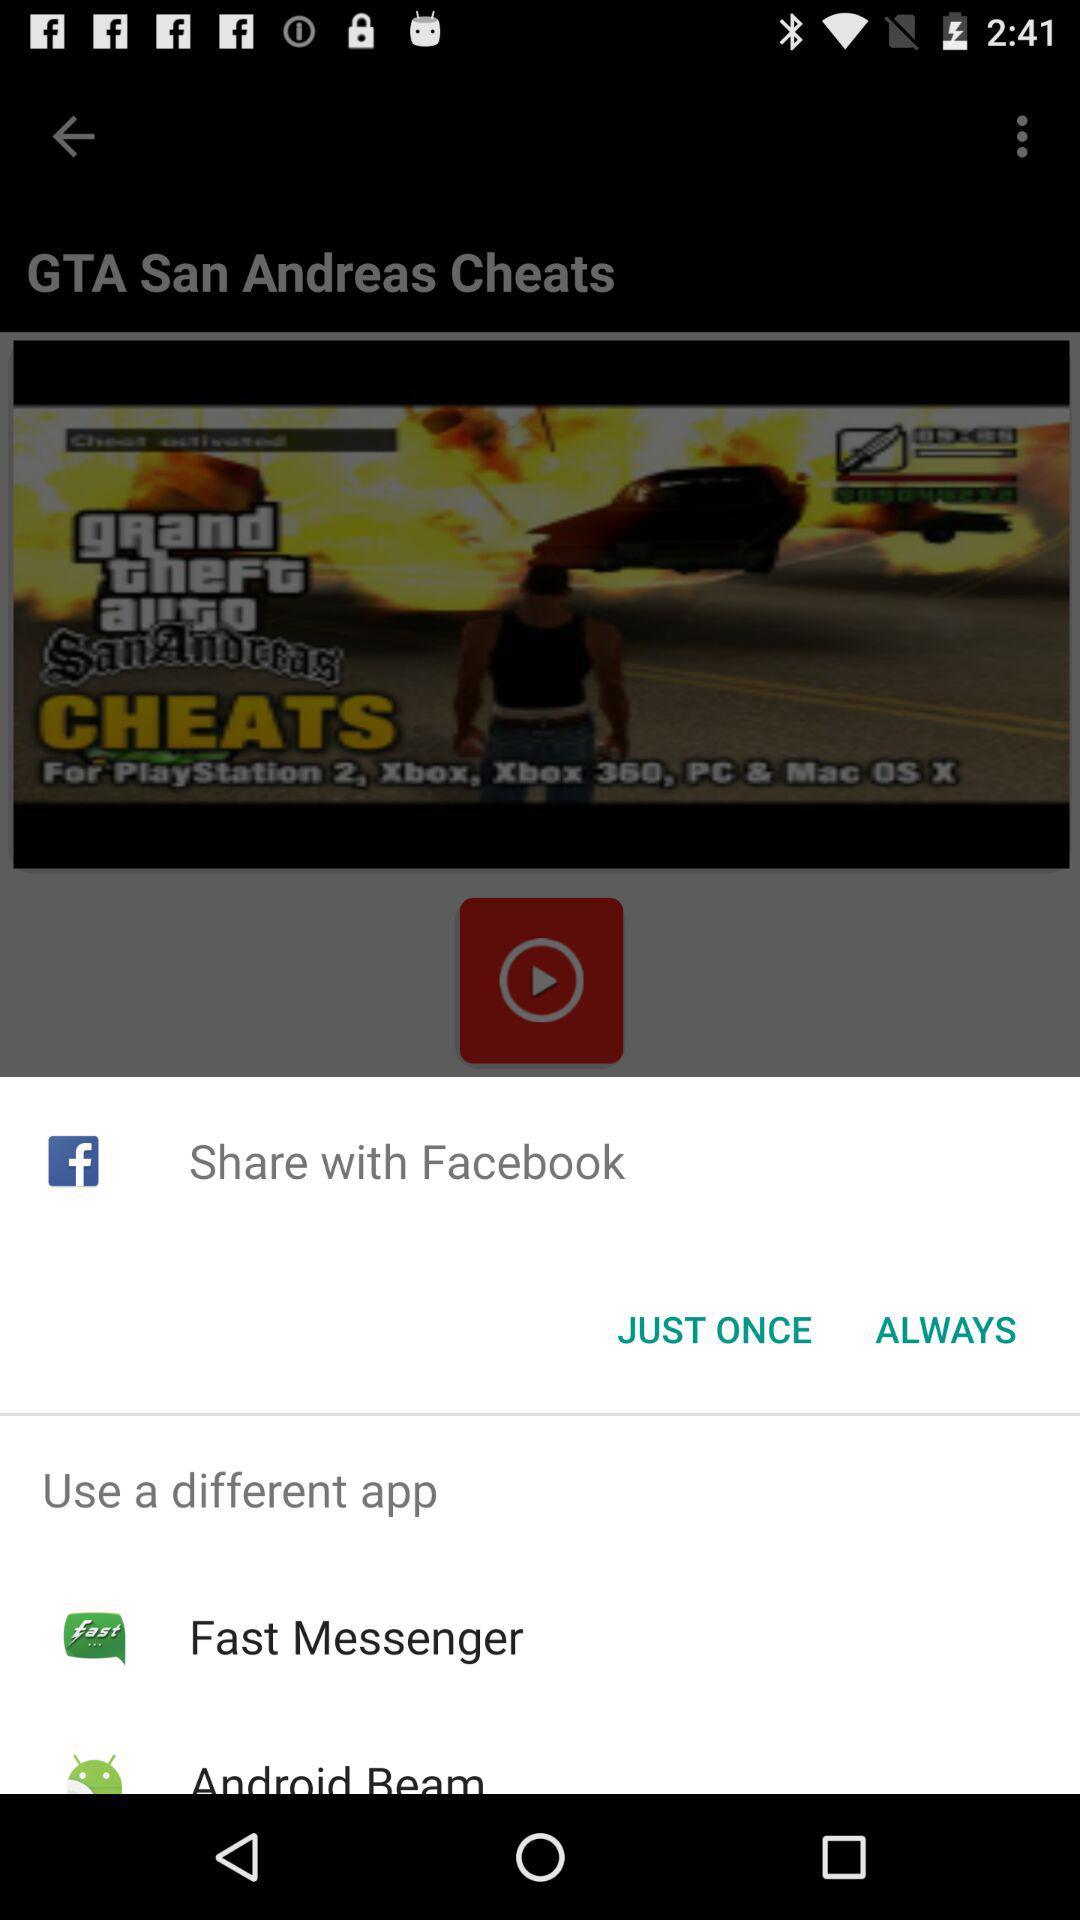What are the different applications through which we can share? You can share through "Facebook", "Fast Messenger" and "Android Beam". 